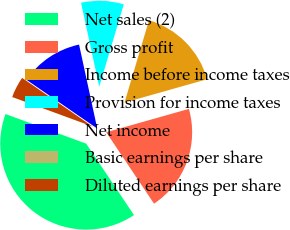<chart> <loc_0><loc_0><loc_500><loc_500><pie_chart><fcel>Net sales (2)<fcel>Gross profit<fcel>Income before income taxes<fcel>Provision for income taxes<fcel>Net income<fcel>Basic earnings per share<fcel>Diluted earnings per share<nl><fcel>39.99%<fcel>20.0%<fcel>16.0%<fcel>8.0%<fcel>12.0%<fcel>0.0%<fcel>4.0%<nl></chart> 